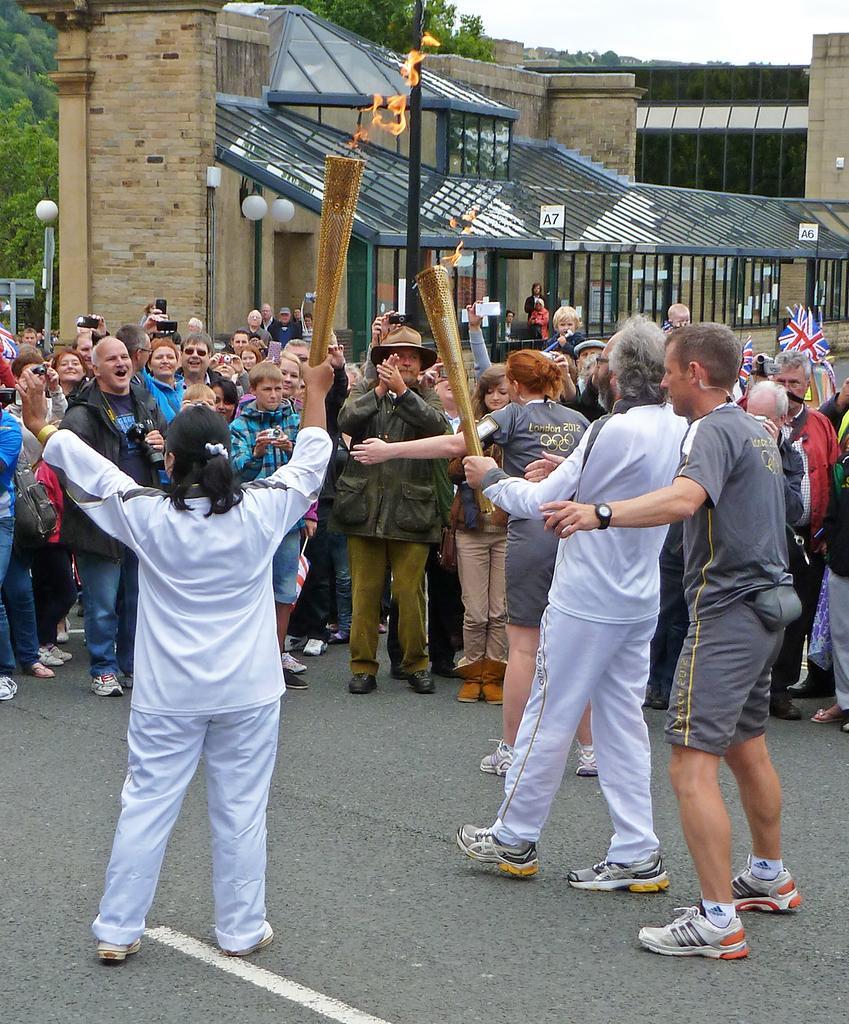Could you give a brief overview of what you see in this image? In this picture there are group of people standing. In the foreground there are two persons standing and holding the objects. At the back there is a building and there are poles and trees. At the top there is sky. At the bottom there is a road. At the back there are flags. 